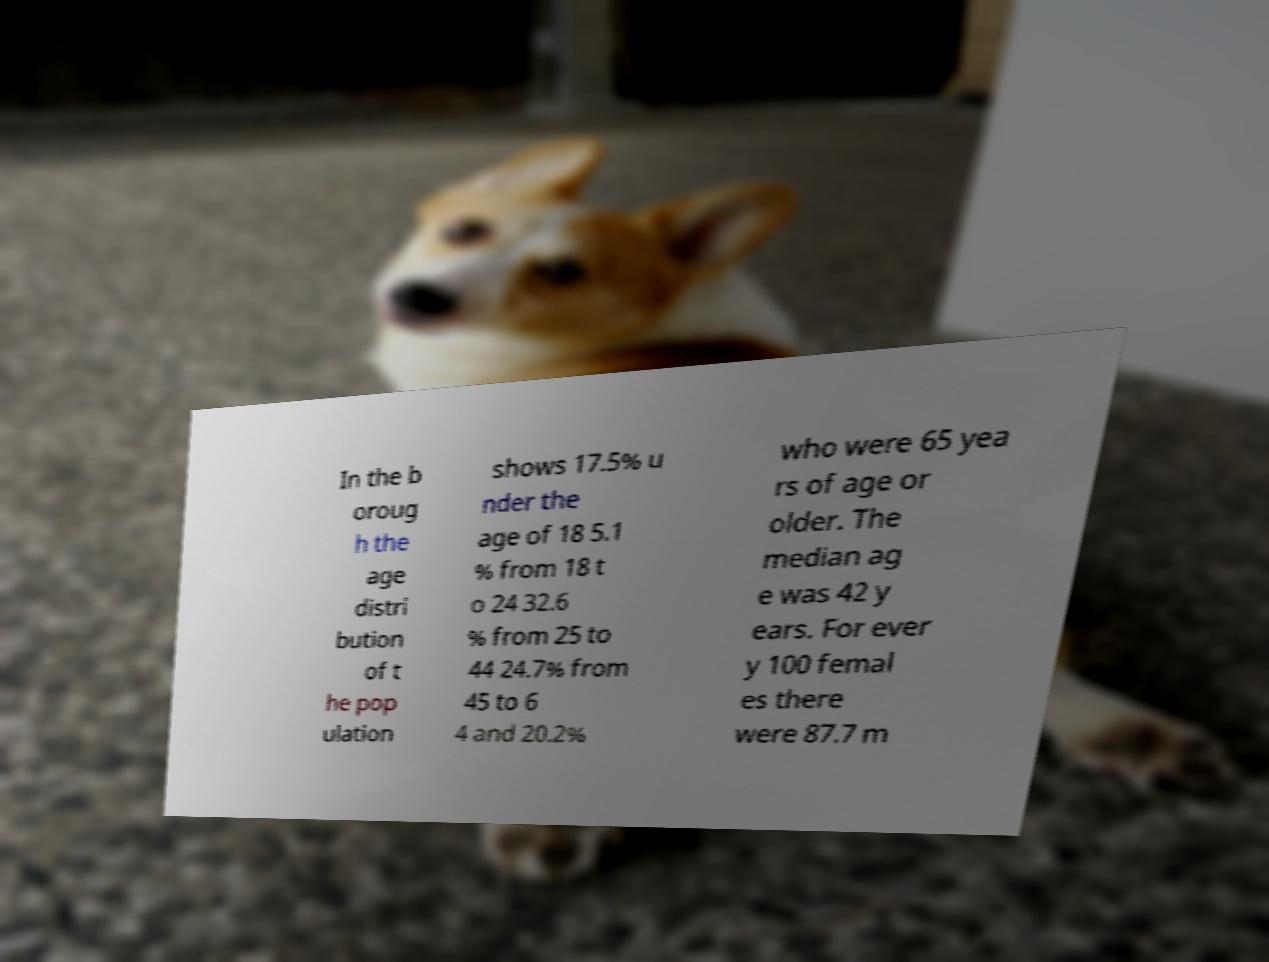Can you read and provide the text displayed in the image?This photo seems to have some interesting text. Can you extract and type it out for me? In the b oroug h the age distri bution of t he pop ulation shows 17.5% u nder the age of 18 5.1 % from 18 t o 24 32.6 % from 25 to 44 24.7% from 45 to 6 4 and 20.2% who were 65 yea rs of age or older. The median ag e was 42 y ears. For ever y 100 femal es there were 87.7 m 